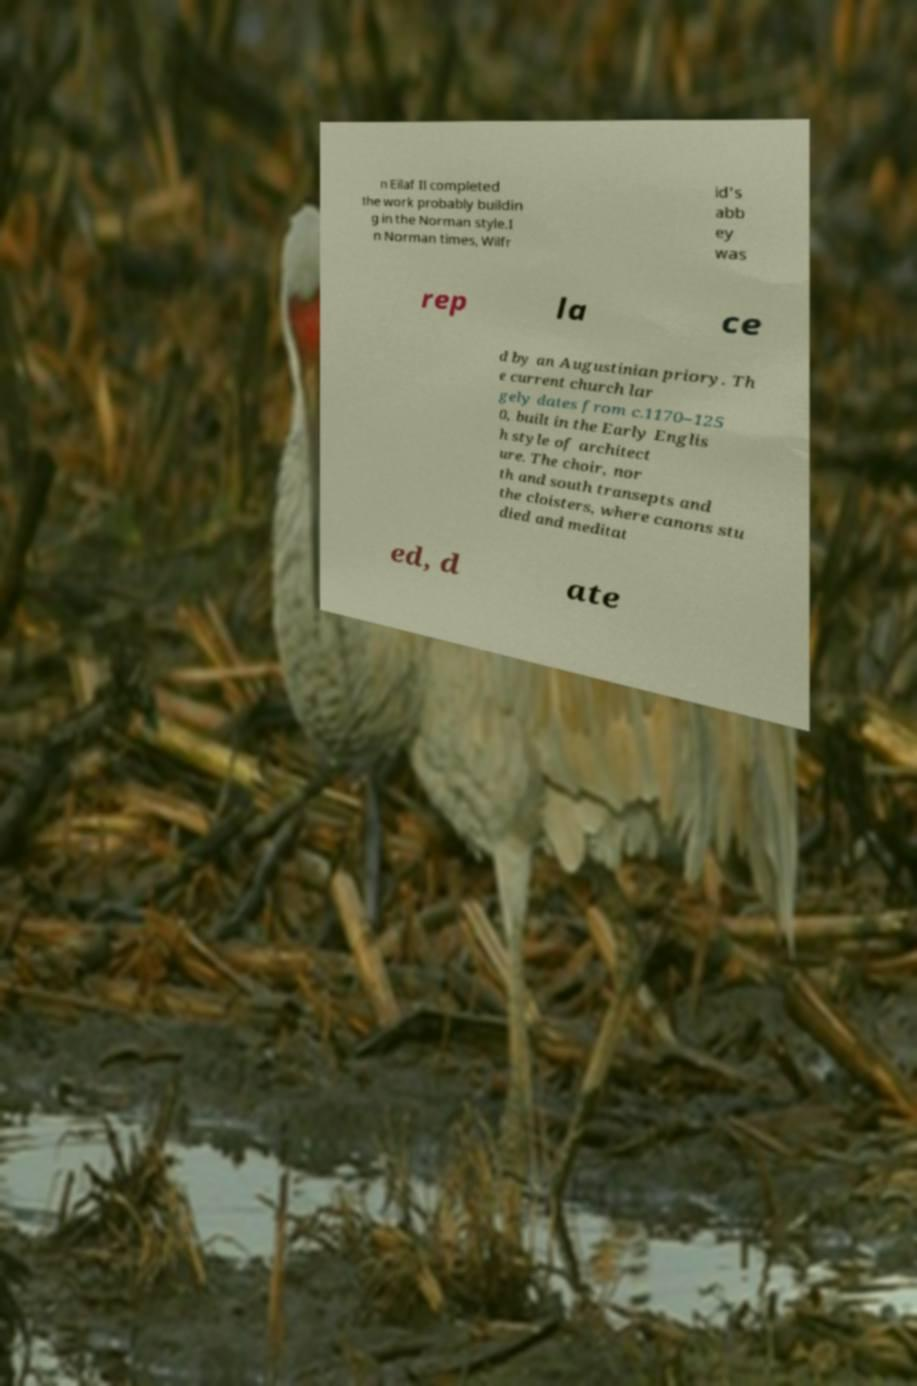Could you extract and type out the text from this image? n Eilaf II completed the work probably buildin g in the Norman style.I n Norman times, Wilfr id's abb ey was rep la ce d by an Augustinian priory. Th e current church lar gely dates from c.1170–125 0, built in the Early Englis h style of architect ure. The choir, nor th and south transepts and the cloisters, where canons stu died and meditat ed, d ate 